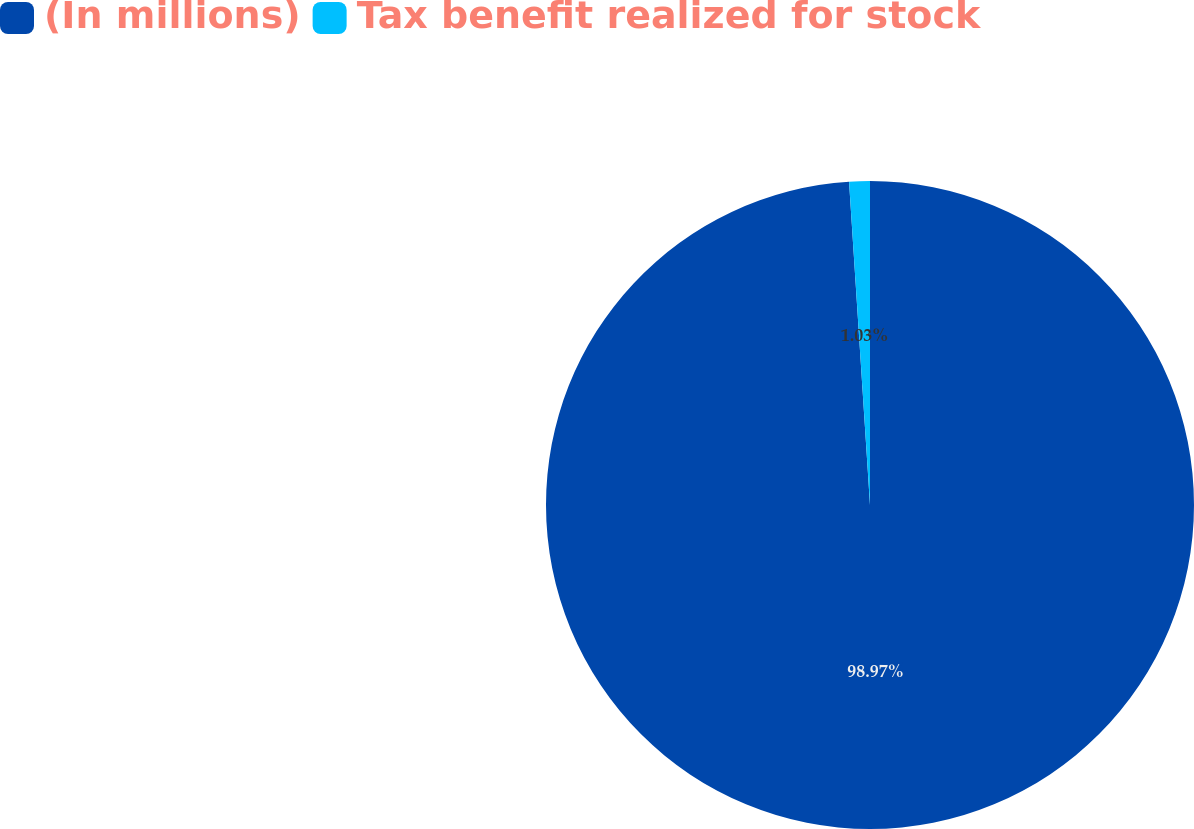<chart> <loc_0><loc_0><loc_500><loc_500><pie_chart><fcel>(In millions)<fcel>Tax benefit realized for stock<nl><fcel>98.97%<fcel>1.03%<nl></chart> 